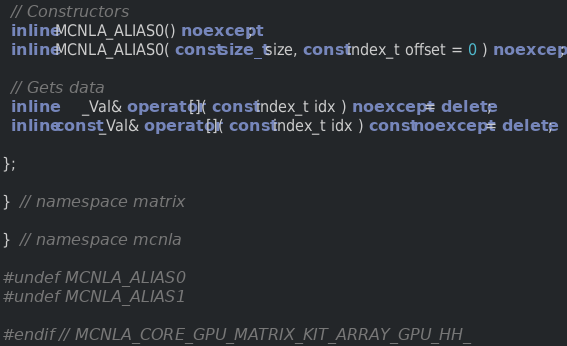Convert code to text. <code><loc_0><loc_0><loc_500><loc_500><_C++_>
  // Constructors
  inline MCNLA_ALIAS0() noexcept;
  inline MCNLA_ALIAS0( const size_t size, const index_t offset = 0 ) noexcept;

  // Gets data
  inline       _Val& operator[]( const index_t idx ) noexcept = delete;
  inline const _Val& operator[]( const index_t idx ) const noexcept = delete;

};

}  // namespace matrix

}  // namespace mcnla

#undef MCNLA_ALIAS0
#undef MCNLA_ALIAS1

#endif  // MCNLA_CORE_GPU_MATRIX_KIT_ARRAY_GPU_HH_
</code> 